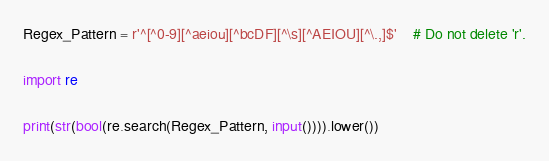<code> <loc_0><loc_0><loc_500><loc_500><_Python_>Regex_Pattern = r'^[^0-9][^aeiou][^bcDF][^\s][^AEIOU][^\.,]$'	# Do not delete 'r'.

import re

print(str(bool(re.search(Regex_Pattern, input()))).lower())
</code> 